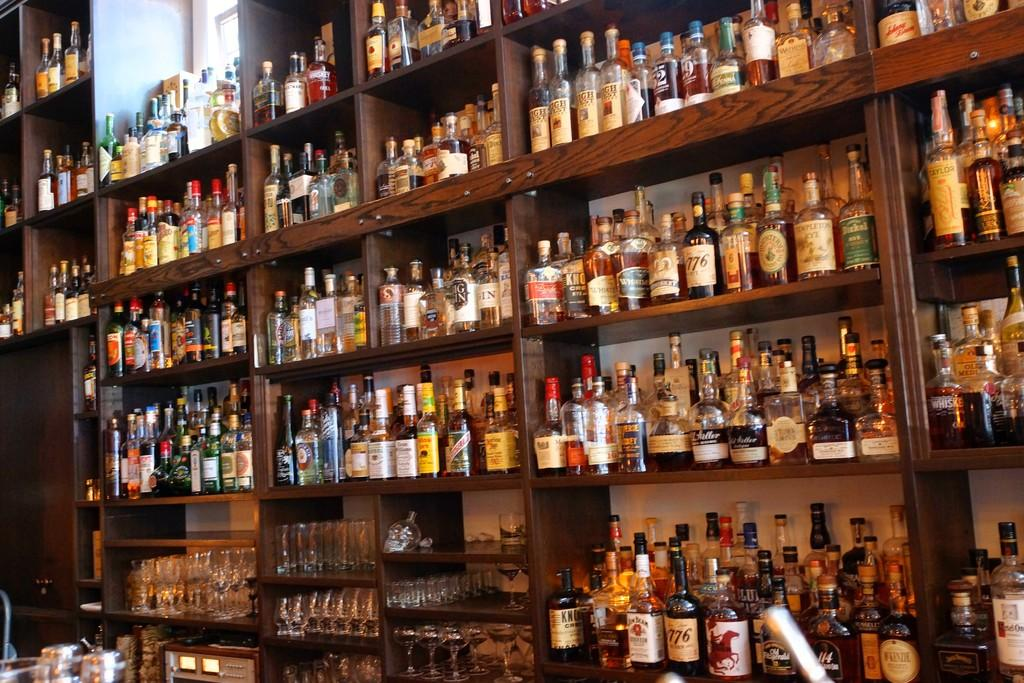What type of bottles are visible in the image? There are wine bottles and beer bottles in the image. How are the bottles arranged in the image? The bottles are placed in a rack. What type of glassware is visible in the image? There are wine glasses and tumblers in the image. How are the wine glasses and tumblers arranged in the image? The wine glasses and tumblers are also placed in the rack. How many police officers are present in the image? There are no police officers present in the image. What is the number of times the earth rotates in the image? The image does not depict the earth or any rotations; it features bottles, glasses, and a rack. 